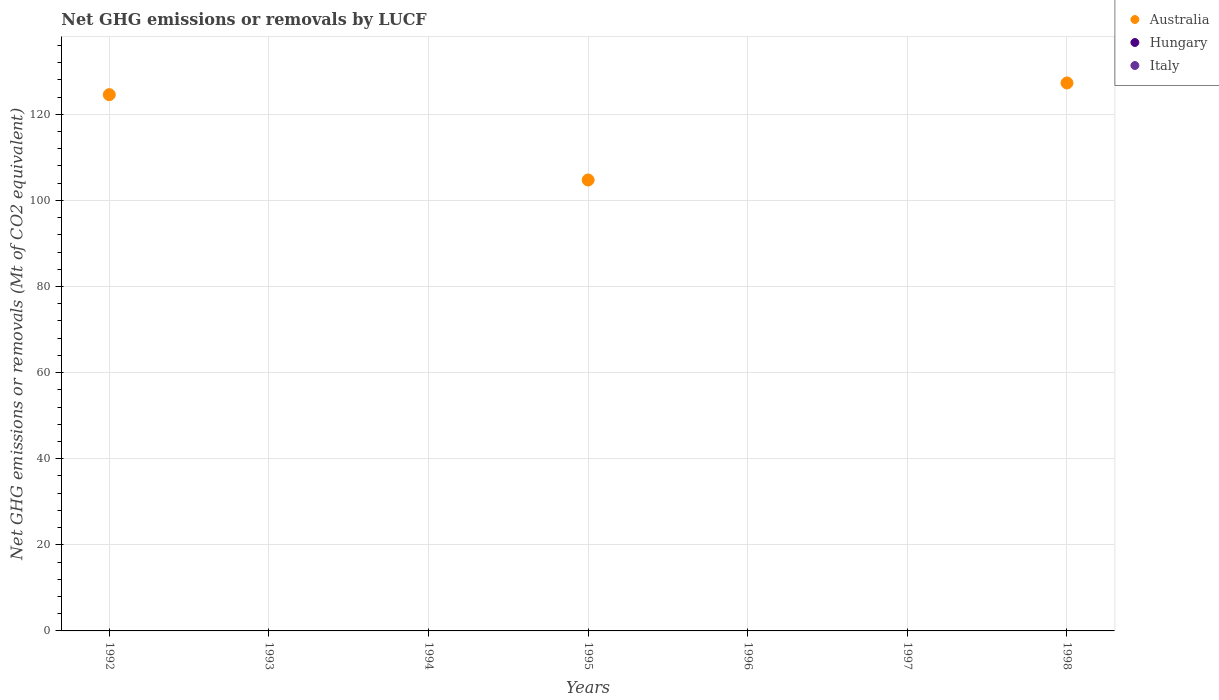How many different coloured dotlines are there?
Ensure brevity in your answer.  1. What is the net GHG emissions or removals by LUCF in Hungary in 1997?
Your response must be concise. 0. Across all years, what is the maximum net GHG emissions or removals by LUCF in Australia?
Provide a short and direct response. 127.29. What is the difference between the net GHG emissions or removals by LUCF in Australia in 1992 and that in 1995?
Provide a succinct answer. 19.82. What is the difference between the net GHG emissions or removals by LUCF in Australia in 1992 and the net GHG emissions or removals by LUCF in Hungary in 1996?
Provide a succinct answer. 124.57. In how many years, is the net GHG emissions or removals by LUCF in Italy greater than 88 Mt?
Ensure brevity in your answer.  0. What is the ratio of the net GHG emissions or removals by LUCF in Australia in 1992 to that in 1998?
Offer a terse response. 0.98. What is the difference between the highest and the second highest net GHG emissions or removals by LUCF in Australia?
Offer a very short reply. 2.72. In how many years, is the net GHG emissions or removals by LUCF in Italy greater than the average net GHG emissions or removals by LUCF in Italy taken over all years?
Your response must be concise. 0. Is the sum of the net GHG emissions or removals by LUCF in Australia in 1992 and 1995 greater than the maximum net GHG emissions or removals by LUCF in Italy across all years?
Give a very brief answer. Yes. Is it the case that in every year, the sum of the net GHG emissions or removals by LUCF in Italy and net GHG emissions or removals by LUCF in Hungary  is greater than the net GHG emissions or removals by LUCF in Australia?
Provide a short and direct response. No. Does the net GHG emissions or removals by LUCF in Australia monotonically increase over the years?
Offer a very short reply. No. Is the net GHG emissions or removals by LUCF in Hungary strictly greater than the net GHG emissions or removals by LUCF in Australia over the years?
Make the answer very short. No. How many dotlines are there?
Offer a terse response. 1. How many years are there in the graph?
Provide a succinct answer. 7. What is the difference between two consecutive major ticks on the Y-axis?
Provide a short and direct response. 20. Does the graph contain any zero values?
Your answer should be very brief. Yes. How are the legend labels stacked?
Your answer should be very brief. Vertical. What is the title of the graph?
Give a very brief answer. Net GHG emissions or removals by LUCF. Does "Colombia" appear as one of the legend labels in the graph?
Ensure brevity in your answer.  No. What is the label or title of the Y-axis?
Your response must be concise. Net GHG emissions or removals (Mt of CO2 equivalent). What is the Net GHG emissions or removals (Mt of CO2 equivalent) of Australia in 1992?
Ensure brevity in your answer.  124.57. What is the Net GHG emissions or removals (Mt of CO2 equivalent) in Hungary in 1992?
Your answer should be very brief. 0. What is the Net GHG emissions or removals (Mt of CO2 equivalent) in Hungary in 1993?
Give a very brief answer. 0. What is the Net GHG emissions or removals (Mt of CO2 equivalent) in Australia in 1994?
Offer a terse response. 0. What is the Net GHG emissions or removals (Mt of CO2 equivalent) of Australia in 1995?
Keep it short and to the point. 104.75. What is the Net GHG emissions or removals (Mt of CO2 equivalent) of Hungary in 1995?
Provide a succinct answer. 0. What is the Net GHG emissions or removals (Mt of CO2 equivalent) in Australia in 1997?
Your answer should be compact. 0. What is the Net GHG emissions or removals (Mt of CO2 equivalent) of Australia in 1998?
Offer a terse response. 127.29. What is the Net GHG emissions or removals (Mt of CO2 equivalent) of Hungary in 1998?
Offer a very short reply. 0. Across all years, what is the maximum Net GHG emissions or removals (Mt of CO2 equivalent) in Australia?
Provide a succinct answer. 127.29. Across all years, what is the minimum Net GHG emissions or removals (Mt of CO2 equivalent) in Australia?
Your answer should be very brief. 0. What is the total Net GHG emissions or removals (Mt of CO2 equivalent) of Australia in the graph?
Give a very brief answer. 356.6. What is the difference between the Net GHG emissions or removals (Mt of CO2 equivalent) in Australia in 1992 and that in 1995?
Make the answer very short. 19.82. What is the difference between the Net GHG emissions or removals (Mt of CO2 equivalent) in Australia in 1992 and that in 1998?
Keep it short and to the point. -2.72. What is the difference between the Net GHG emissions or removals (Mt of CO2 equivalent) of Australia in 1995 and that in 1998?
Provide a short and direct response. -22.54. What is the average Net GHG emissions or removals (Mt of CO2 equivalent) in Australia per year?
Your response must be concise. 50.94. What is the average Net GHG emissions or removals (Mt of CO2 equivalent) in Italy per year?
Provide a short and direct response. 0. What is the ratio of the Net GHG emissions or removals (Mt of CO2 equivalent) in Australia in 1992 to that in 1995?
Offer a terse response. 1.19. What is the ratio of the Net GHG emissions or removals (Mt of CO2 equivalent) in Australia in 1992 to that in 1998?
Provide a succinct answer. 0.98. What is the ratio of the Net GHG emissions or removals (Mt of CO2 equivalent) of Australia in 1995 to that in 1998?
Your answer should be very brief. 0.82. What is the difference between the highest and the second highest Net GHG emissions or removals (Mt of CO2 equivalent) in Australia?
Your response must be concise. 2.72. What is the difference between the highest and the lowest Net GHG emissions or removals (Mt of CO2 equivalent) in Australia?
Your answer should be very brief. 127.29. 